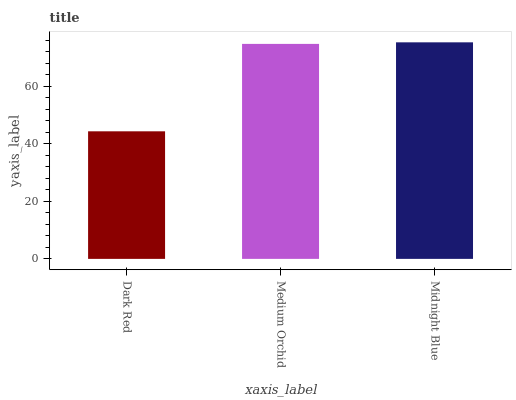Is Dark Red the minimum?
Answer yes or no. Yes. Is Midnight Blue the maximum?
Answer yes or no. Yes. Is Medium Orchid the minimum?
Answer yes or no. No. Is Medium Orchid the maximum?
Answer yes or no. No. Is Medium Orchid greater than Dark Red?
Answer yes or no. Yes. Is Dark Red less than Medium Orchid?
Answer yes or no. Yes. Is Dark Red greater than Medium Orchid?
Answer yes or no. No. Is Medium Orchid less than Dark Red?
Answer yes or no. No. Is Medium Orchid the high median?
Answer yes or no. Yes. Is Medium Orchid the low median?
Answer yes or no. Yes. Is Dark Red the high median?
Answer yes or no. No. Is Midnight Blue the low median?
Answer yes or no. No. 